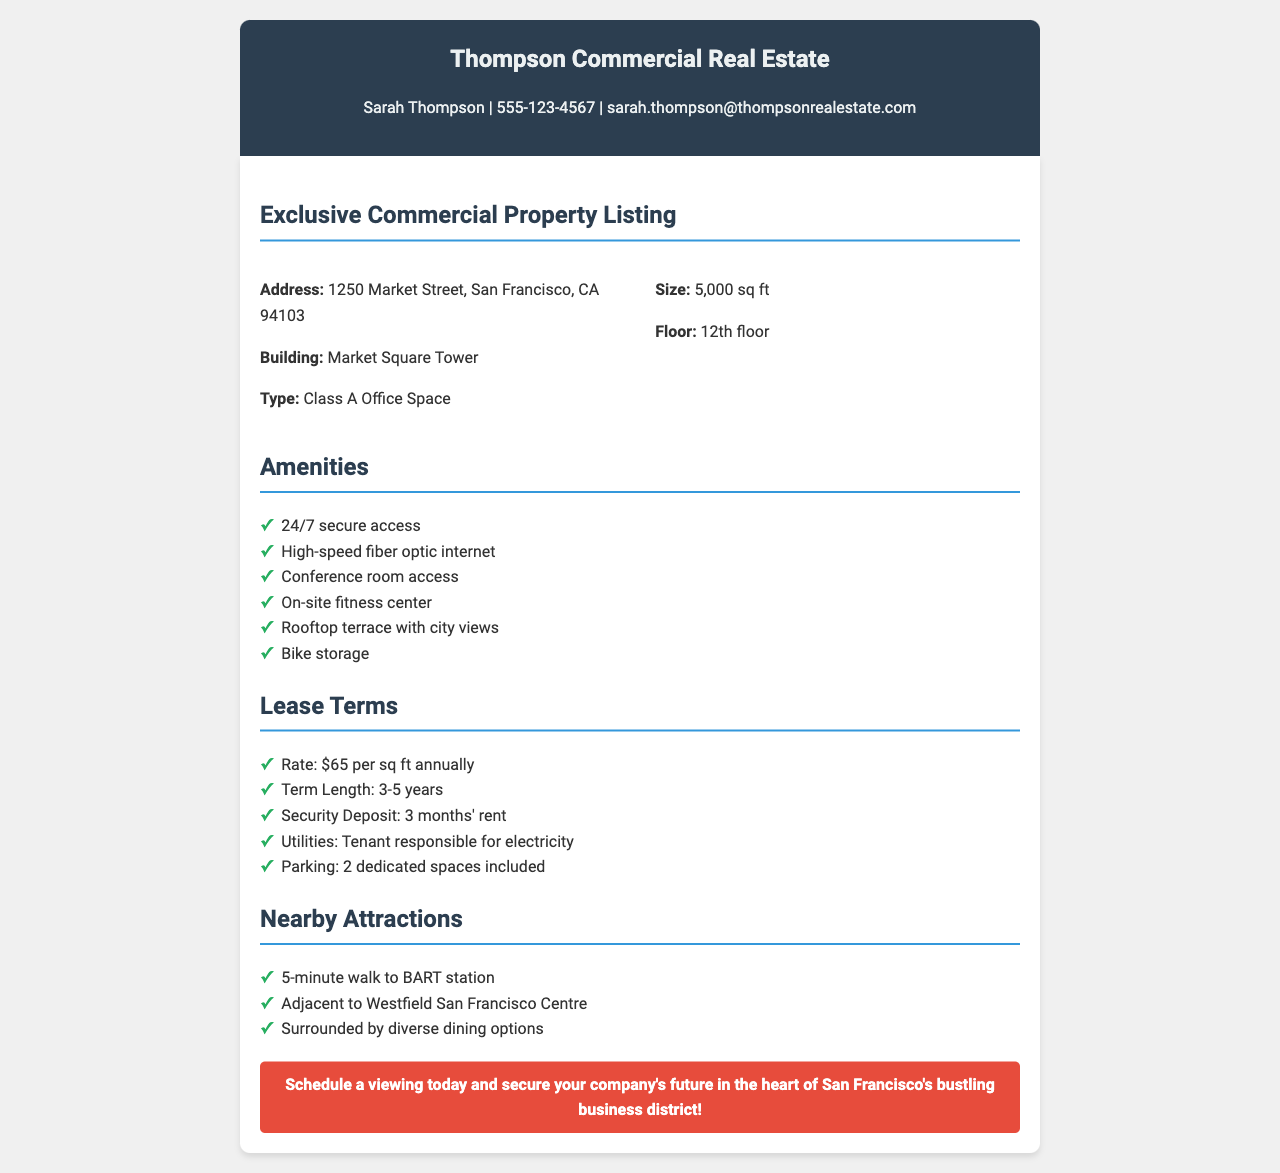What is the address of the property? The address is mentioned in the property details section of the document.
Answer: 1250 Market Street, San Francisco, CA 94103 What is the size of the commercial space? The size of the space is specified as part of the property details.
Answer: 5,000 sq ft What floor is the office space located on? The floor number is provided in the property details section.
Answer: 12th floor What amenities are included? The document lists specific amenities available in the property.
Answer: 24/7 secure access, High-speed fiber optic internet, Conference room access, On-site fitness center, Rooftop terrace with city views, Bike storage What is the annual lease rate per square foot? The lease rate is detailed in the lease terms section.
Answer: $65 per sq ft annually How long is the lease term? The term length is indicated under lease terms in the document.
Answer: 3-5 years What is the security deposit amount? The security deposit amount is specified in the lease terms section.
Answer: 3 months' rent What parking is included with the lease? The parking specifications are clarified in the lease terms of the document.
Answer: 2 dedicated spaces Is there a fitness center on-site? This information can be found in the amenities section.
Answer: Yes How far is the nearest BART station? The distance to the BART station is provided in the nearby attractions section.
Answer: 5-minute walk 